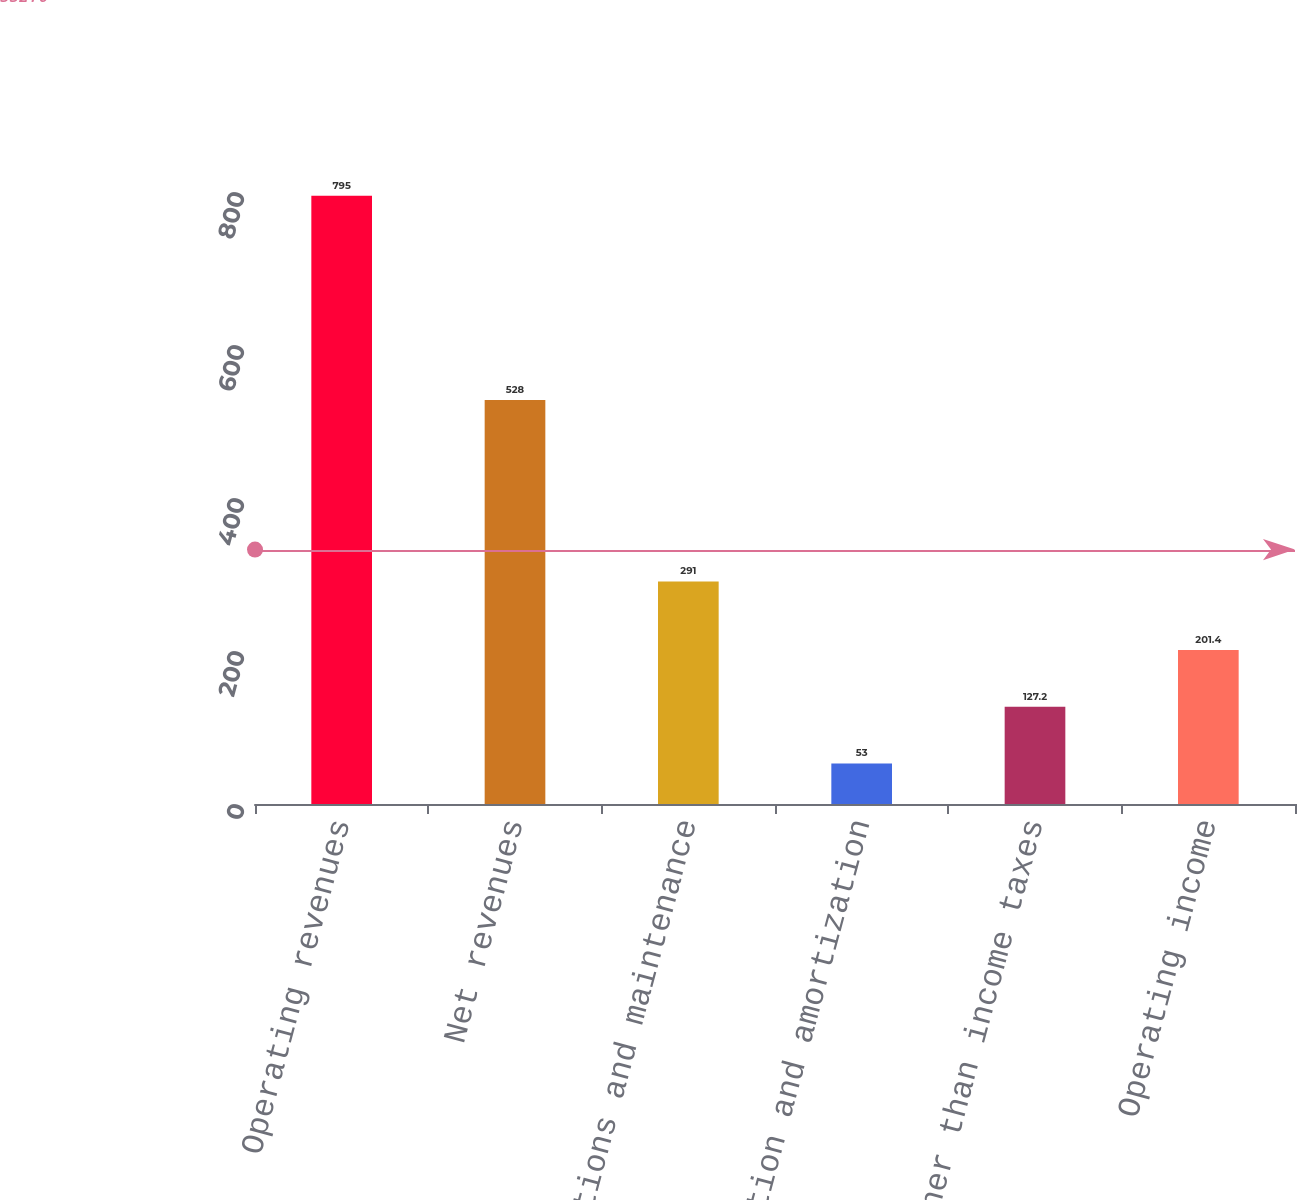Convert chart to OTSL. <chart><loc_0><loc_0><loc_500><loc_500><bar_chart><fcel>Operating revenues<fcel>Net revenues<fcel>Operations and maintenance<fcel>Depreciation and amortization<fcel>Taxes other than income taxes<fcel>Operating income<nl><fcel>795<fcel>528<fcel>291<fcel>53<fcel>127.2<fcel>201.4<nl></chart> 